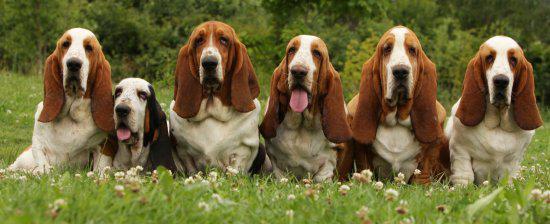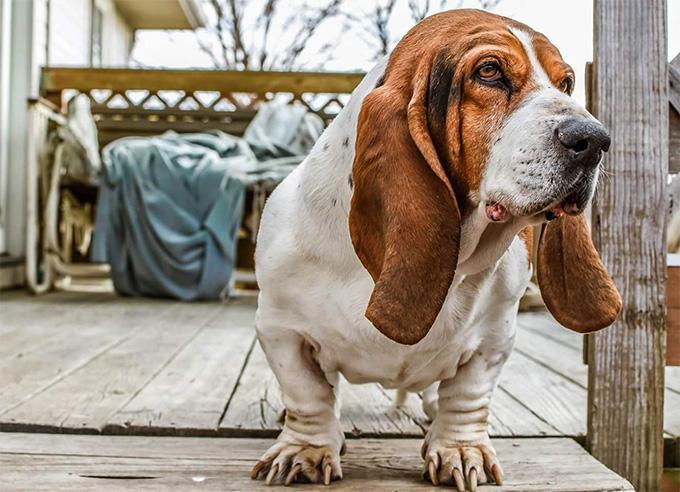The first image is the image on the left, the second image is the image on the right. For the images displayed, is the sentence "There are two dogs in the image pair." factually correct? Answer yes or no. No. The first image is the image on the left, the second image is the image on the right. Analyze the images presented: Is the assertion "A hound dog is running forward on the green grass." valid? Answer yes or no. No. 